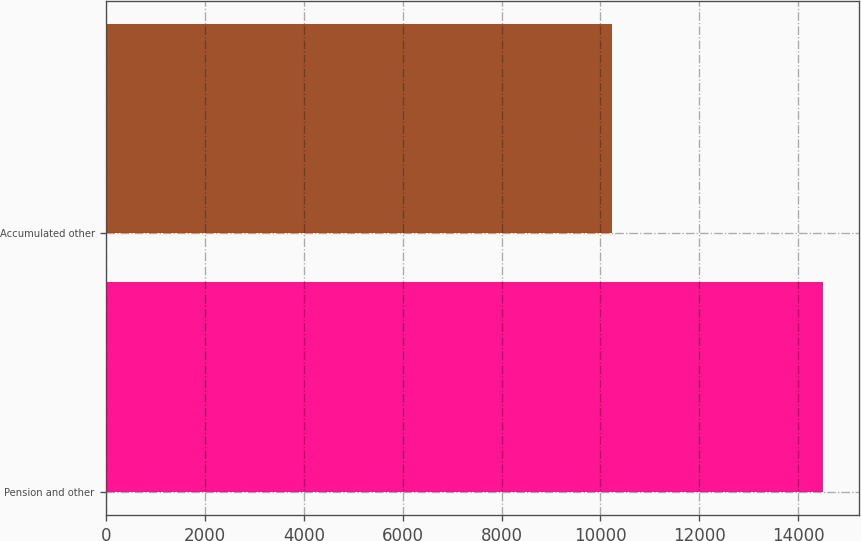Convert chart to OTSL. <chart><loc_0><loc_0><loc_500><loc_500><bar_chart><fcel>Pension and other<fcel>Accumulated other<nl><fcel>14509<fcel>10226<nl></chart> 